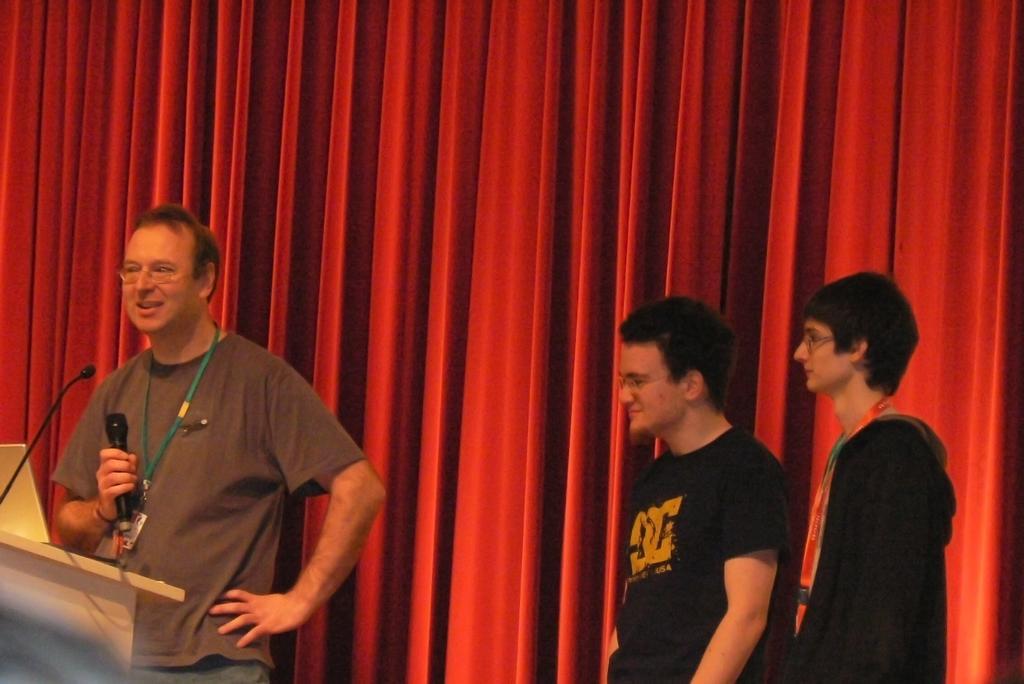Could you give a brief overview of what you see in this image? On the right side, there is a person in a t-shirt, smiling, standing and holding a mic with one hand in front of a stand on which, there is a mic. On the right side, there are two persons in black color dresses, standing. In the background, there is an orange color curtain. 